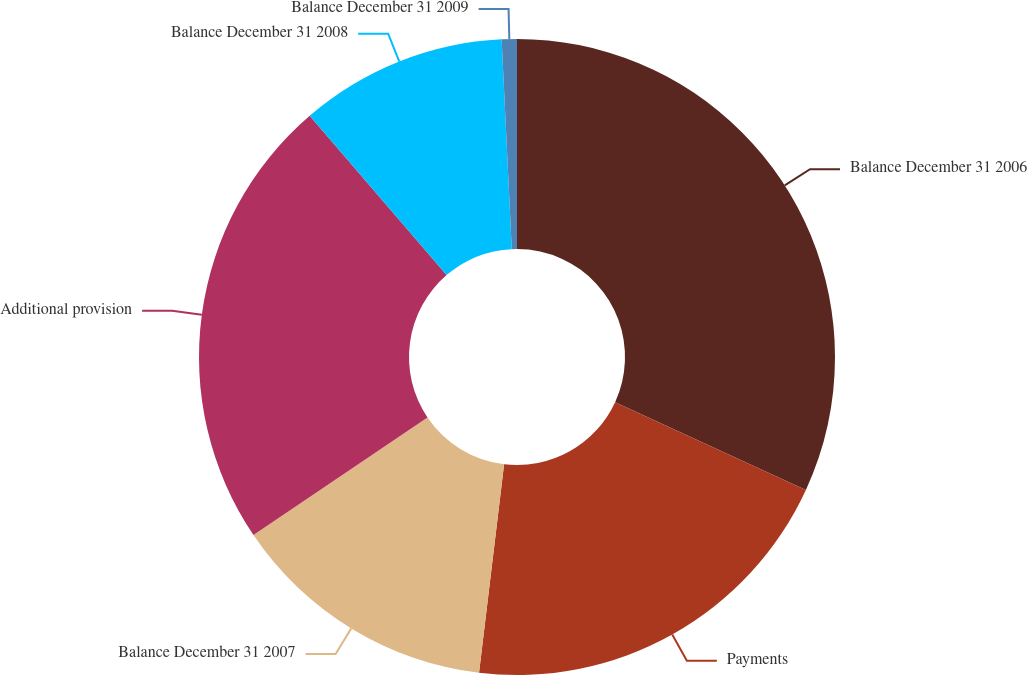Convert chart to OTSL. <chart><loc_0><loc_0><loc_500><loc_500><pie_chart><fcel>Balance December 31 2006<fcel>Payments<fcel>Balance December 31 2007<fcel>Additional provision<fcel>Balance December 31 2008<fcel>Balance December 31 2009<nl><fcel>31.86%<fcel>20.04%<fcel>13.64%<fcel>23.15%<fcel>10.53%<fcel>0.77%<nl></chart> 